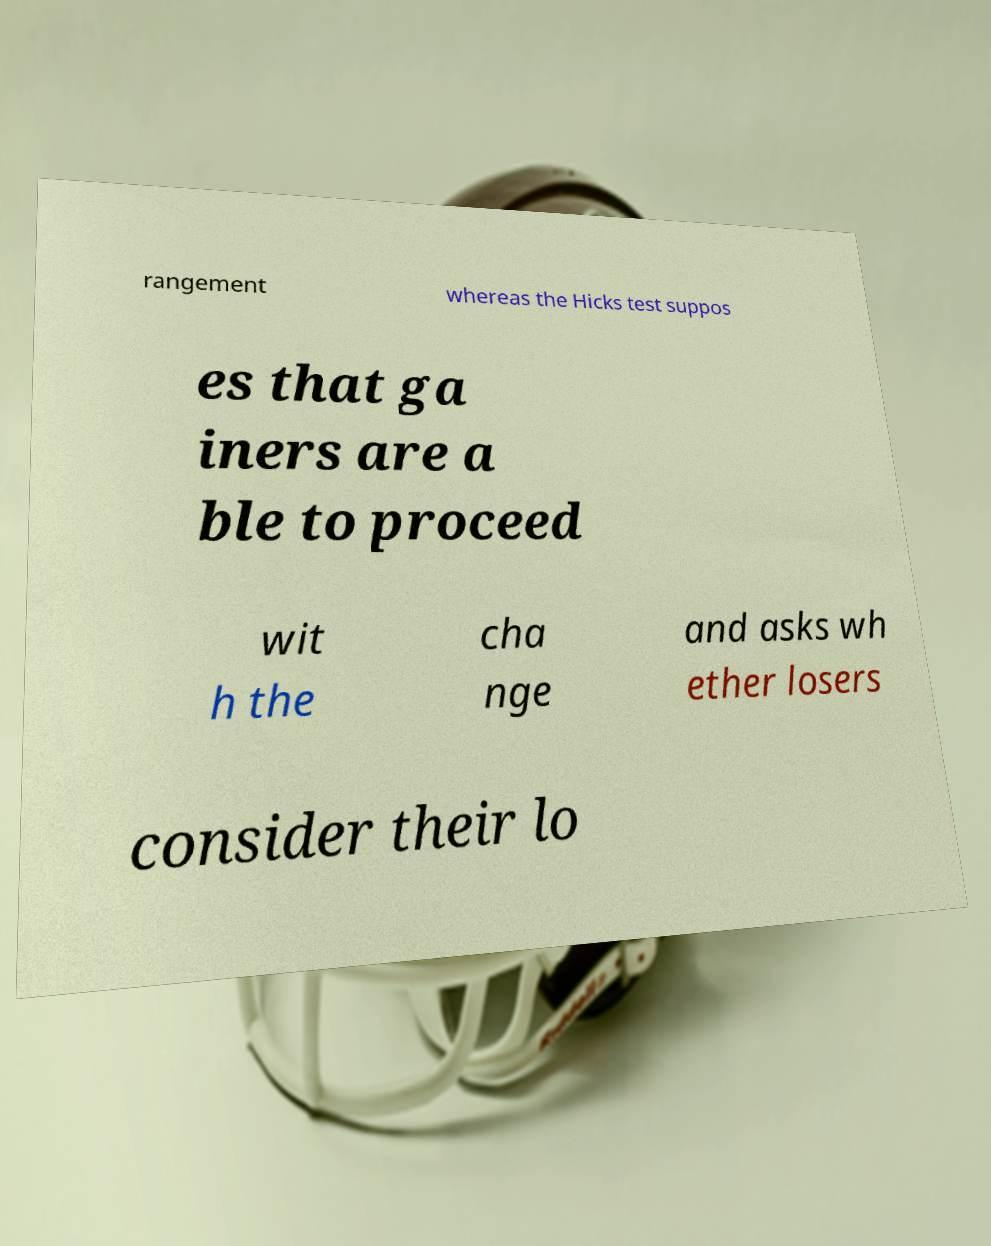Please read and relay the text visible in this image. What does it say? rangement whereas the Hicks test suppos es that ga iners are a ble to proceed wit h the cha nge and asks wh ether losers consider their lo 